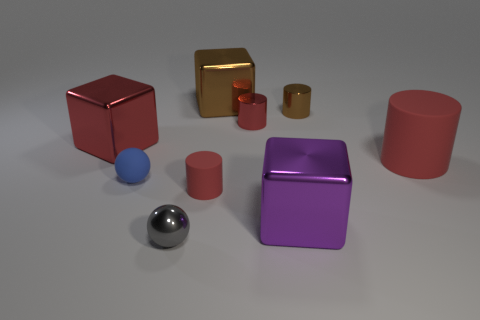Are there more red blocks that are right of the brown metallic cylinder than metallic cylinders?
Ensure brevity in your answer.  No. What number of other objects are there of the same size as the gray metal ball?
Your response must be concise. 4. What number of objects are behind the tiny red shiny thing and in front of the brown cube?
Offer a terse response. 1. Does the tiny ball that is in front of the purple object have the same material as the big red cube?
Ensure brevity in your answer.  Yes. There is a red matte thing in front of the rubber object that is right of the metallic cube that is to the right of the large brown block; what shape is it?
Offer a very short reply. Cylinder. Are there the same number of large brown metal cubes behind the big brown metal thing and tiny objects behind the large red cylinder?
Keep it short and to the point. No. What is the color of the rubber cylinder that is the same size as the gray metallic sphere?
Your response must be concise. Red. What number of large things are either brown metal cubes or blue matte balls?
Ensure brevity in your answer.  1. There is a tiny object that is both right of the gray metallic sphere and in front of the blue matte ball; what is its material?
Keep it short and to the point. Rubber. There is a red matte thing in front of the small matte sphere; does it have the same shape as the red shiny object to the left of the gray ball?
Your answer should be compact. No. 